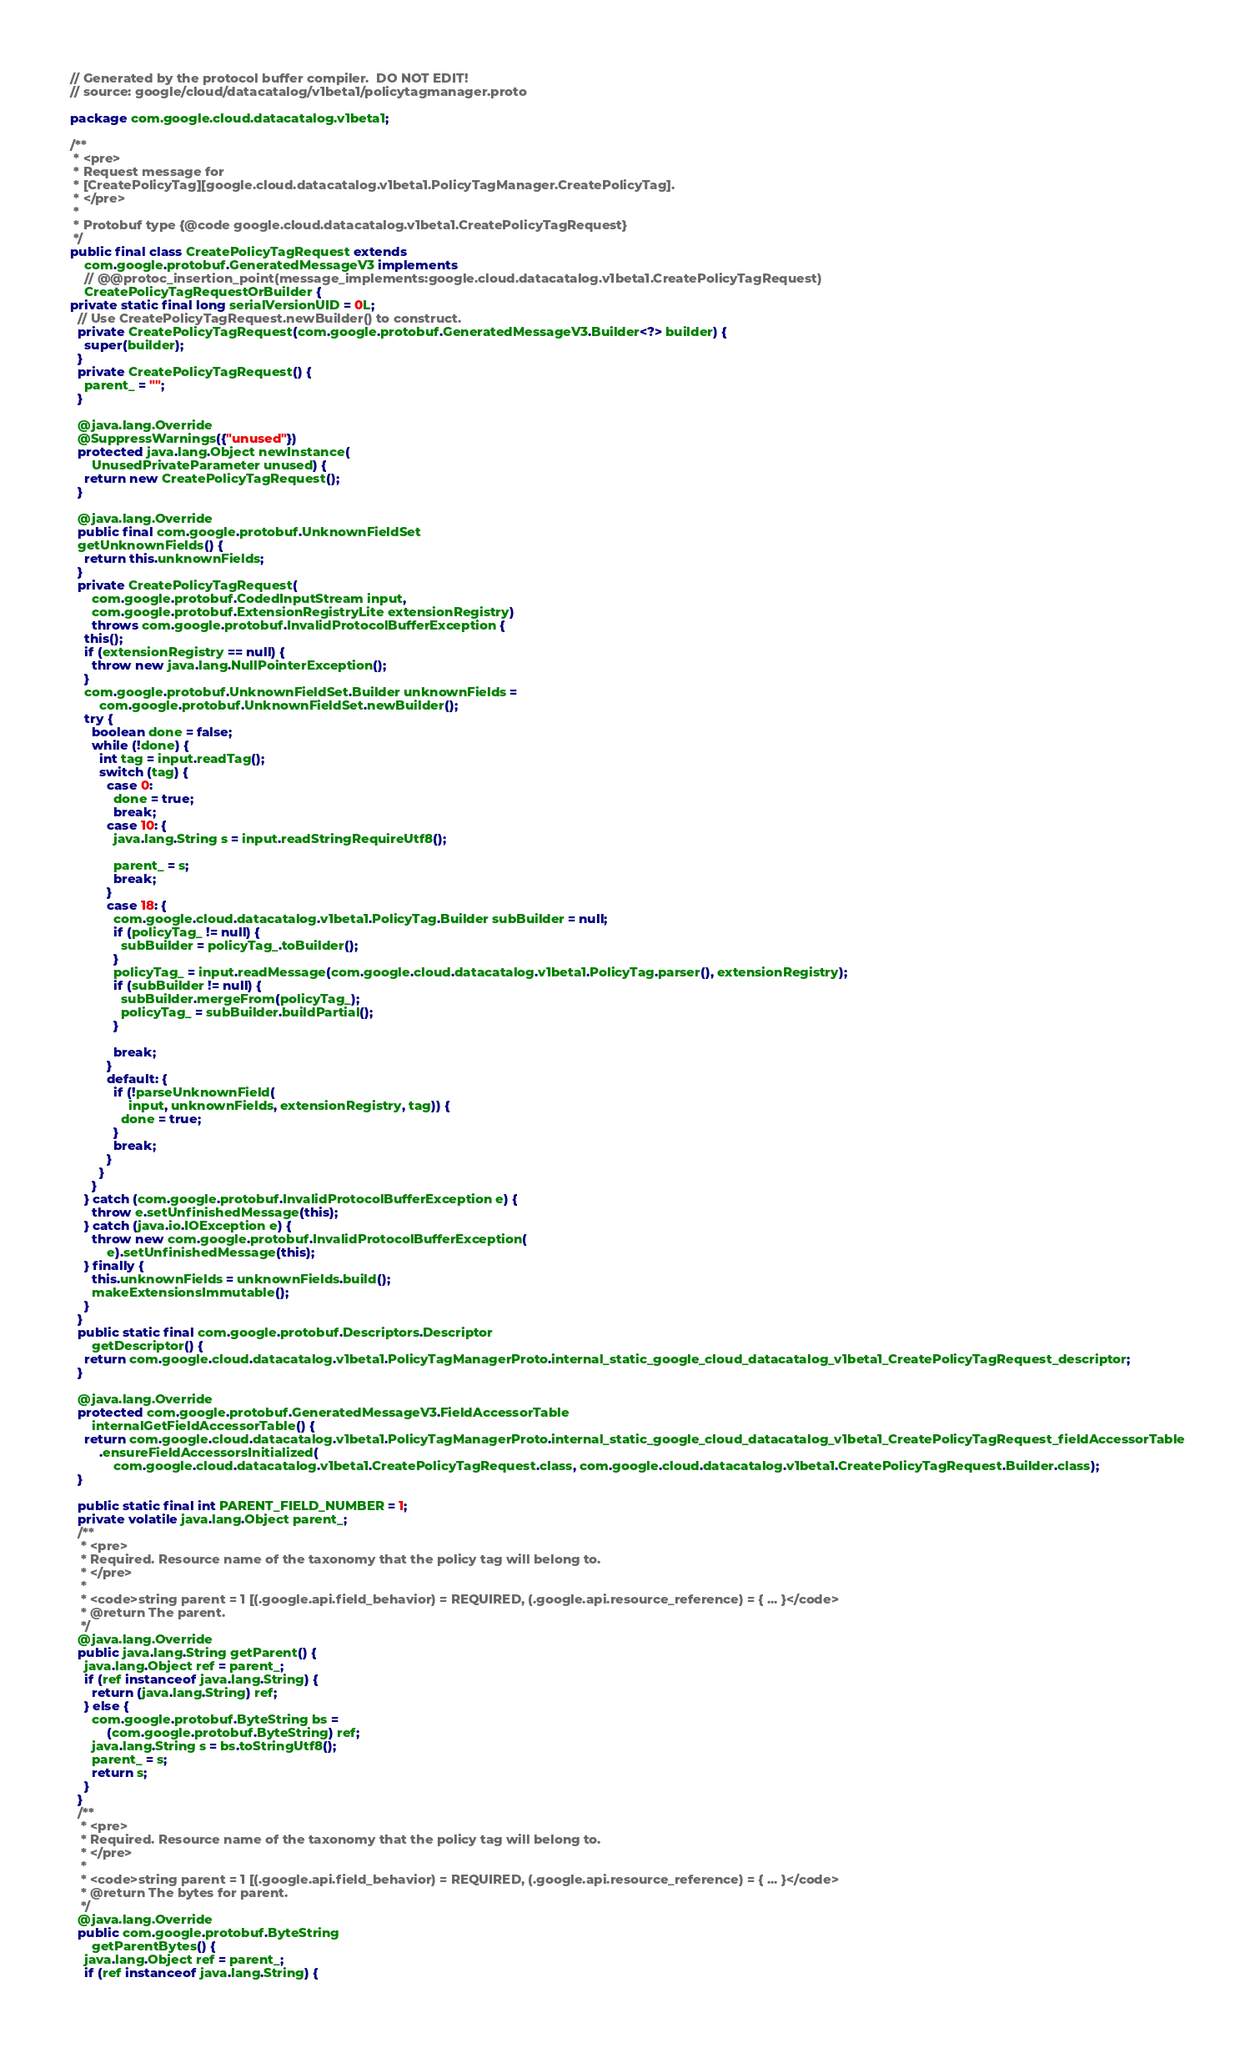Convert code to text. <code><loc_0><loc_0><loc_500><loc_500><_Java_>// Generated by the protocol buffer compiler.  DO NOT EDIT!
// source: google/cloud/datacatalog/v1beta1/policytagmanager.proto

package com.google.cloud.datacatalog.v1beta1;

/**
 * <pre>
 * Request message for
 * [CreatePolicyTag][google.cloud.datacatalog.v1beta1.PolicyTagManager.CreatePolicyTag].
 * </pre>
 *
 * Protobuf type {@code google.cloud.datacatalog.v1beta1.CreatePolicyTagRequest}
 */
public final class CreatePolicyTagRequest extends
    com.google.protobuf.GeneratedMessageV3 implements
    // @@protoc_insertion_point(message_implements:google.cloud.datacatalog.v1beta1.CreatePolicyTagRequest)
    CreatePolicyTagRequestOrBuilder {
private static final long serialVersionUID = 0L;
  // Use CreatePolicyTagRequest.newBuilder() to construct.
  private CreatePolicyTagRequest(com.google.protobuf.GeneratedMessageV3.Builder<?> builder) {
    super(builder);
  }
  private CreatePolicyTagRequest() {
    parent_ = "";
  }

  @java.lang.Override
  @SuppressWarnings({"unused"})
  protected java.lang.Object newInstance(
      UnusedPrivateParameter unused) {
    return new CreatePolicyTagRequest();
  }

  @java.lang.Override
  public final com.google.protobuf.UnknownFieldSet
  getUnknownFields() {
    return this.unknownFields;
  }
  private CreatePolicyTagRequest(
      com.google.protobuf.CodedInputStream input,
      com.google.protobuf.ExtensionRegistryLite extensionRegistry)
      throws com.google.protobuf.InvalidProtocolBufferException {
    this();
    if (extensionRegistry == null) {
      throw new java.lang.NullPointerException();
    }
    com.google.protobuf.UnknownFieldSet.Builder unknownFields =
        com.google.protobuf.UnknownFieldSet.newBuilder();
    try {
      boolean done = false;
      while (!done) {
        int tag = input.readTag();
        switch (tag) {
          case 0:
            done = true;
            break;
          case 10: {
            java.lang.String s = input.readStringRequireUtf8();

            parent_ = s;
            break;
          }
          case 18: {
            com.google.cloud.datacatalog.v1beta1.PolicyTag.Builder subBuilder = null;
            if (policyTag_ != null) {
              subBuilder = policyTag_.toBuilder();
            }
            policyTag_ = input.readMessage(com.google.cloud.datacatalog.v1beta1.PolicyTag.parser(), extensionRegistry);
            if (subBuilder != null) {
              subBuilder.mergeFrom(policyTag_);
              policyTag_ = subBuilder.buildPartial();
            }

            break;
          }
          default: {
            if (!parseUnknownField(
                input, unknownFields, extensionRegistry, tag)) {
              done = true;
            }
            break;
          }
        }
      }
    } catch (com.google.protobuf.InvalidProtocolBufferException e) {
      throw e.setUnfinishedMessage(this);
    } catch (java.io.IOException e) {
      throw new com.google.protobuf.InvalidProtocolBufferException(
          e).setUnfinishedMessage(this);
    } finally {
      this.unknownFields = unknownFields.build();
      makeExtensionsImmutable();
    }
  }
  public static final com.google.protobuf.Descriptors.Descriptor
      getDescriptor() {
    return com.google.cloud.datacatalog.v1beta1.PolicyTagManagerProto.internal_static_google_cloud_datacatalog_v1beta1_CreatePolicyTagRequest_descriptor;
  }

  @java.lang.Override
  protected com.google.protobuf.GeneratedMessageV3.FieldAccessorTable
      internalGetFieldAccessorTable() {
    return com.google.cloud.datacatalog.v1beta1.PolicyTagManagerProto.internal_static_google_cloud_datacatalog_v1beta1_CreatePolicyTagRequest_fieldAccessorTable
        .ensureFieldAccessorsInitialized(
            com.google.cloud.datacatalog.v1beta1.CreatePolicyTagRequest.class, com.google.cloud.datacatalog.v1beta1.CreatePolicyTagRequest.Builder.class);
  }

  public static final int PARENT_FIELD_NUMBER = 1;
  private volatile java.lang.Object parent_;
  /**
   * <pre>
   * Required. Resource name of the taxonomy that the policy tag will belong to.
   * </pre>
   *
   * <code>string parent = 1 [(.google.api.field_behavior) = REQUIRED, (.google.api.resource_reference) = { ... }</code>
   * @return The parent.
   */
  @java.lang.Override
  public java.lang.String getParent() {
    java.lang.Object ref = parent_;
    if (ref instanceof java.lang.String) {
      return (java.lang.String) ref;
    } else {
      com.google.protobuf.ByteString bs = 
          (com.google.protobuf.ByteString) ref;
      java.lang.String s = bs.toStringUtf8();
      parent_ = s;
      return s;
    }
  }
  /**
   * <pre>
   * Required. Resource name of the taxonomy that the policy tag will belong to.
   * </pre>
   *
   * <code>string parent = 1 [(.google.api.field_behavior) = REQUIRED, (.google.api.resource_reference) = { ... }</code>
   * @return The bytes for parent.
   */
  @java.lang.Override
  public com.google.protobuf.ByteString
      getParentBytes() {
    java.lang.Object ref = parent_;
    if (ref instanceof java.lang.String) {</code> 